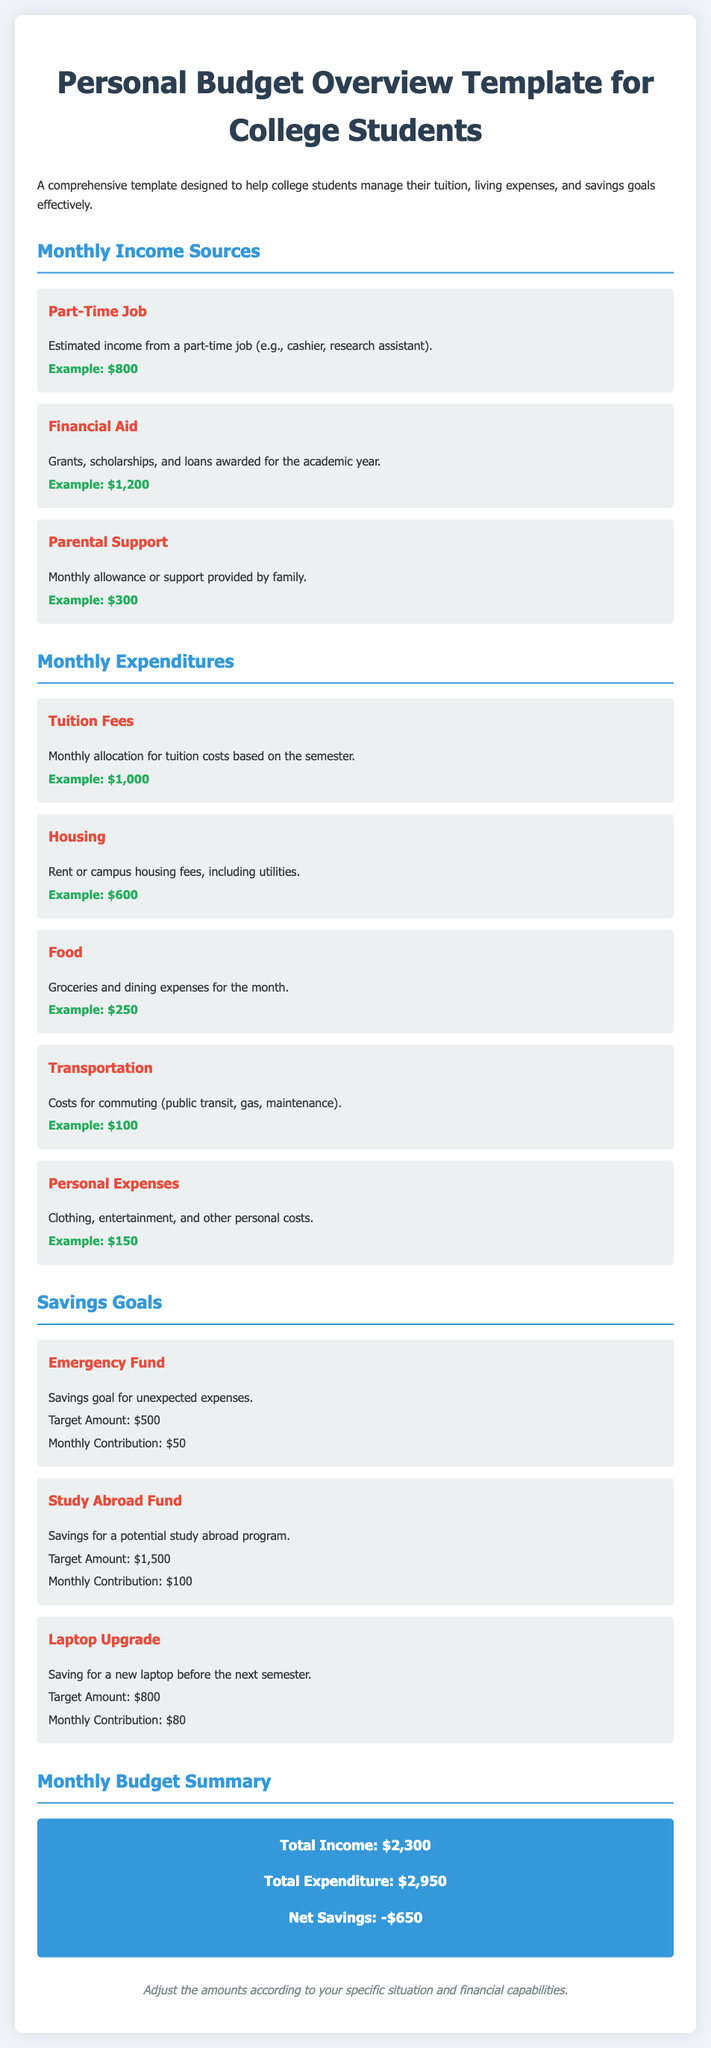what is the estimated income from a part-time job? The estimated income from a part-time job is specified in the document, which is $800.
Answer: $800 what is the target amount for the emergency fund? The document outlines the target amount for the emergency fund, stated as $500.
Answer: $500 how much is allocated monthly for food? The document indicates that the monthly allocation for food is $250.
Answer: $250 what are the total income and total expenditure amounts? The total income is $2,300 and the total expenditure is $2,950, as summarized in the document.
Answer: $2,300 and $2,950 what is the monthly contribution for the Laptop Upgrade goal? The document specifically mentions that the monthly contribution for the Laptop Upgrade is $80.
Answer: $80 what is the net savings amount according to the budget summary? The document shows that the net savings amount is -$650, indicating a deficit.
Answer: -$650 how much parental support is mentioned in the income sources? The document specifies the amount of parental support is $300.
Answer: $300 what is included in the personal expenses category? The personal expenses category includes costs for clothing, entertainment, and other personal costs as stated in the document.
Answer: Clothing, entertainment, and other personal costs 